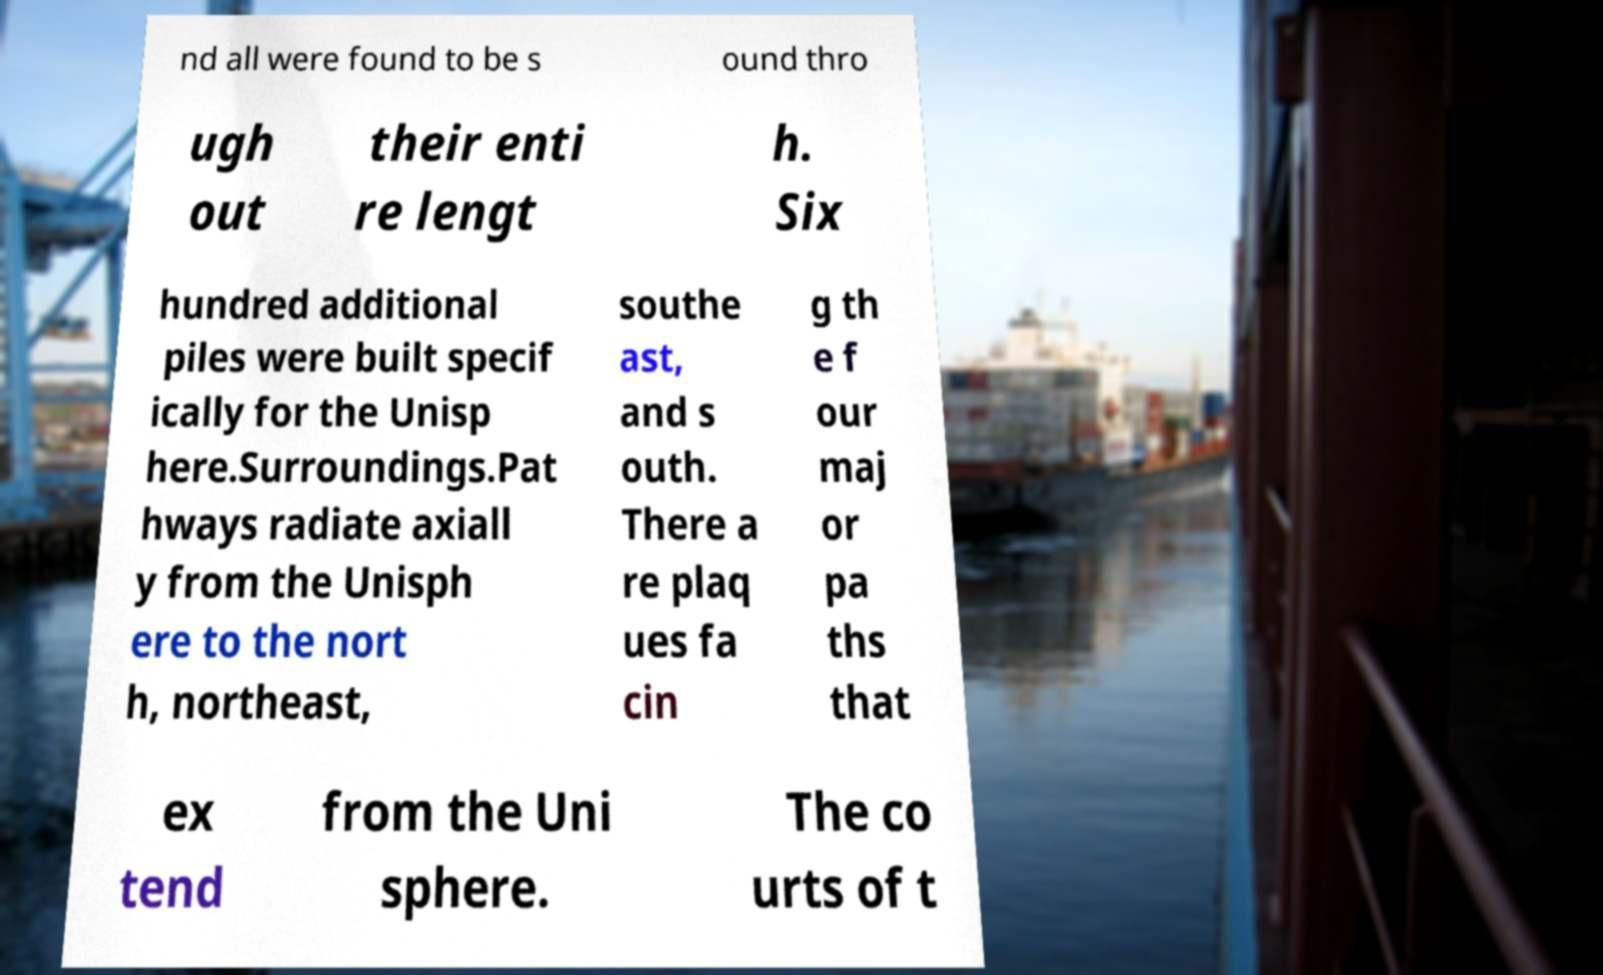Can you accurately transcribe the text from the provided image for me? nd all were found to be s ound thro ugh out their enti re lengt h. Six hundred additional piles were built specif ically for the Unisp here.Surroundings.Pat hways radiate axiall y from the Unisph ere to the nort h, northeast, southe ast, and s outh. There a re plaq ues fa cin g th e f our maj or pa ths that ex tend from the Uni sphere. The co urts of t 